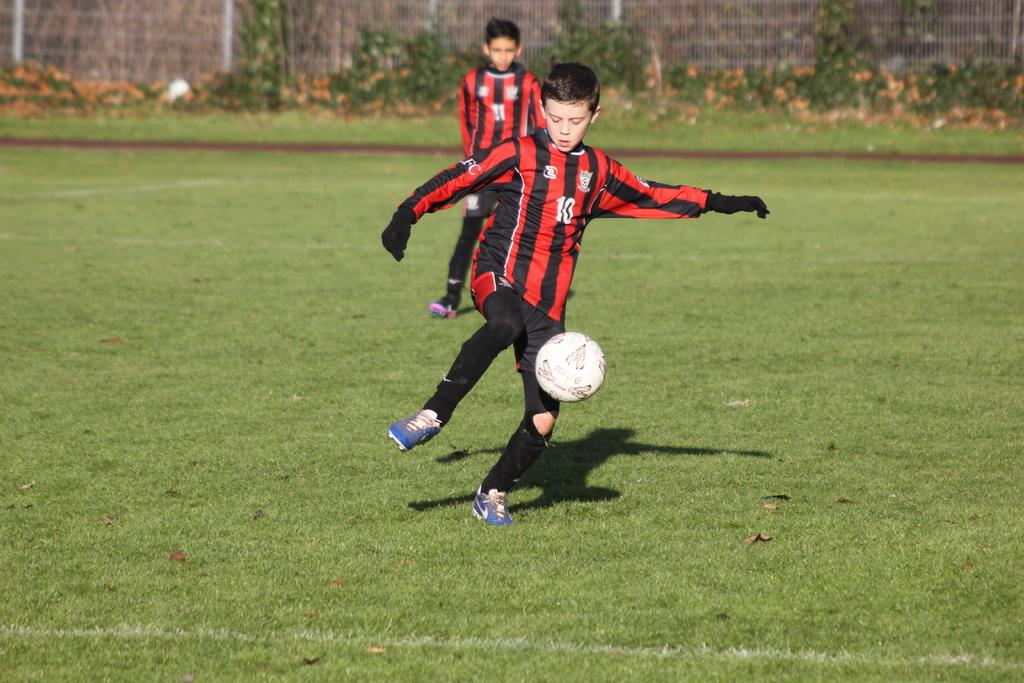What is the main subject of the image? There is a boy standing in the image. What object is in front of the boy? There is a football in front of the boy. Can you describe the other person in the image? There is another person in the background of the image. What color are the jerseys worn by the boy and the other person? Both the boy and the other person are wearing red-colored jerseys. What type of glove is the boy wearing in the image? There is no glove visible in the image; the boy and the other person are wearing red-colored jerseys. 